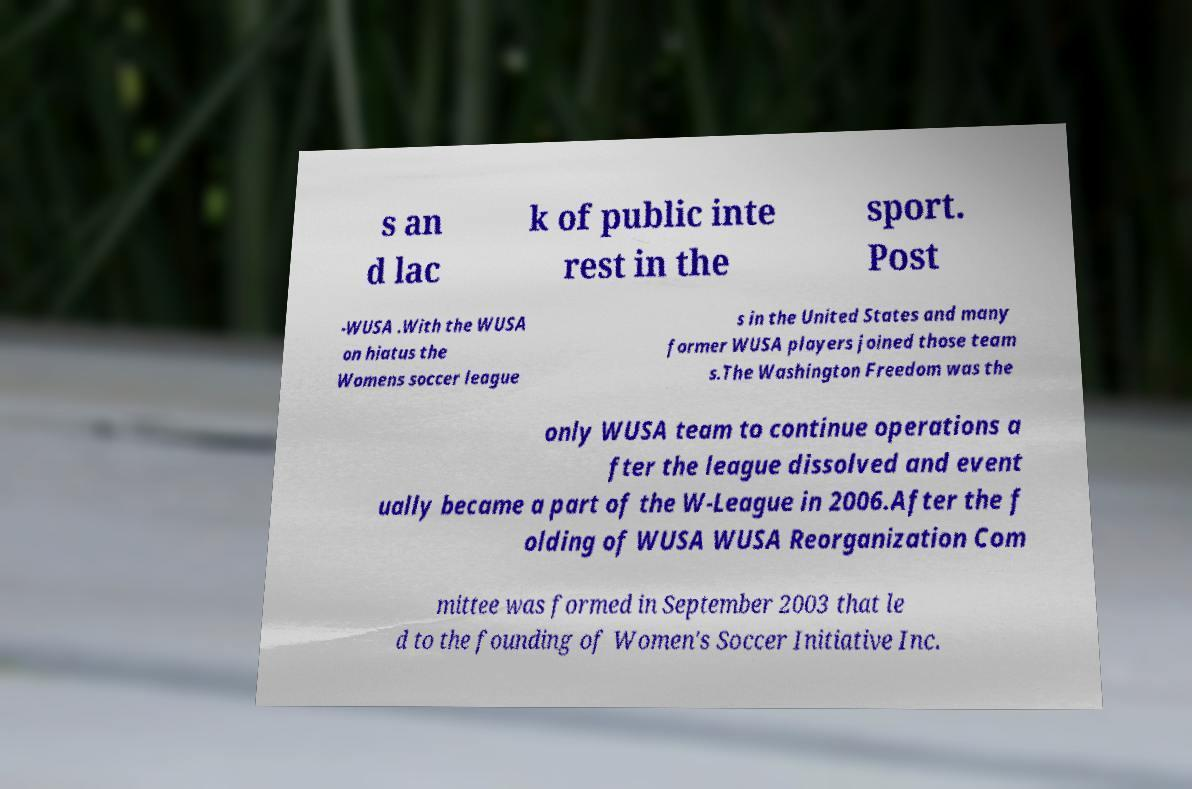Please identify and transcribe the text found in this image. s an d lac k of public inte rest in the sport. Post -WUSA .With the WUSA on hiatus the Womens soccer league s in the United States and many former WUSA players joined those team s.The Washington Freedom was the only WUSA team to continue operations a fter the league dissolved and event ually became a part of the W-League in 2006.After the f olding of WUSA WUSA Reorganization Com mittee was formed in September 2003 that le d to the founding of Women's Soccer Initiative Inc. 